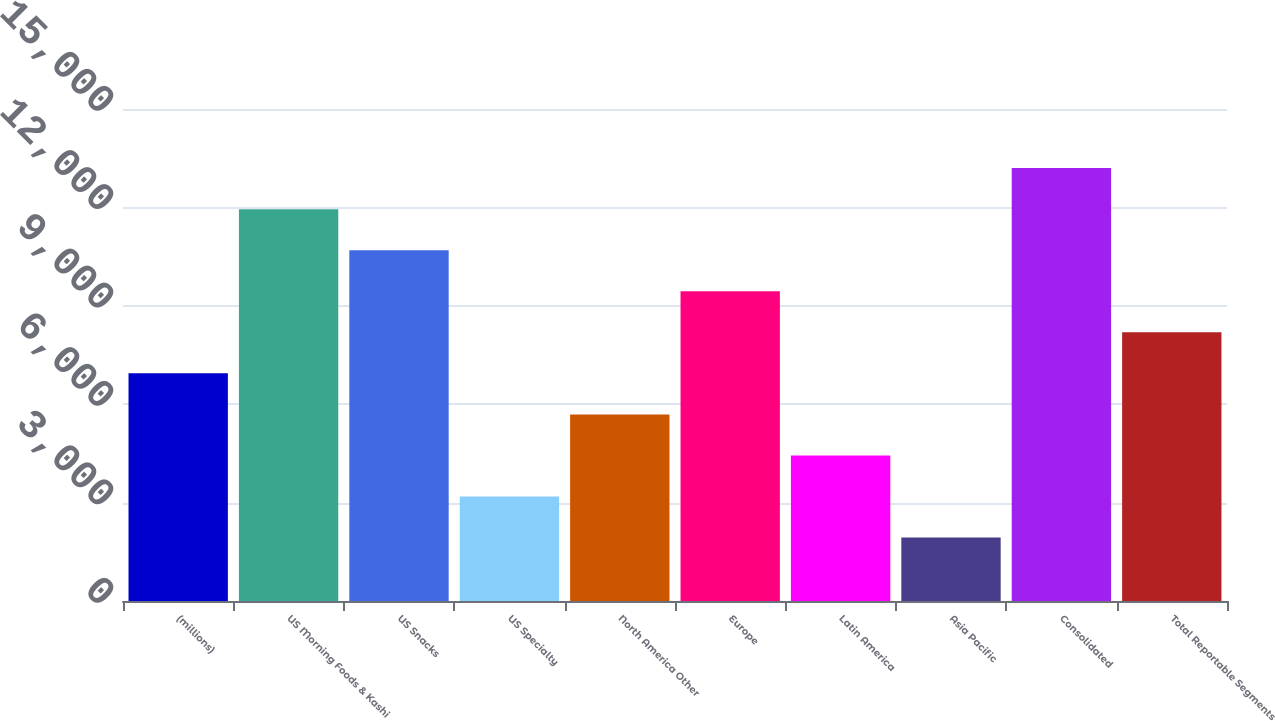Convert chart. <chart><loc_0><loc_0><loc_500><loc_500><bar_chart><fcel>(millions)<fcel>US Morning Foods & Kashi<fcel>US Snacks<fcel>US Specialty<fcel>North America Other<fcel>Europe<fcel>Latin America<fcel>Asia Pacific<fcel>Consolidated<fcel>Total Reportable Segments<nl><fcel>6941<fcel>11946.6<fcel>10695.2<fcel>3186.8<fcel>5689.6<fcel>9443.8<fcel>4438.2<fcel>1935.4<fcel>13198<fcel>8192.4<nl></chart> 